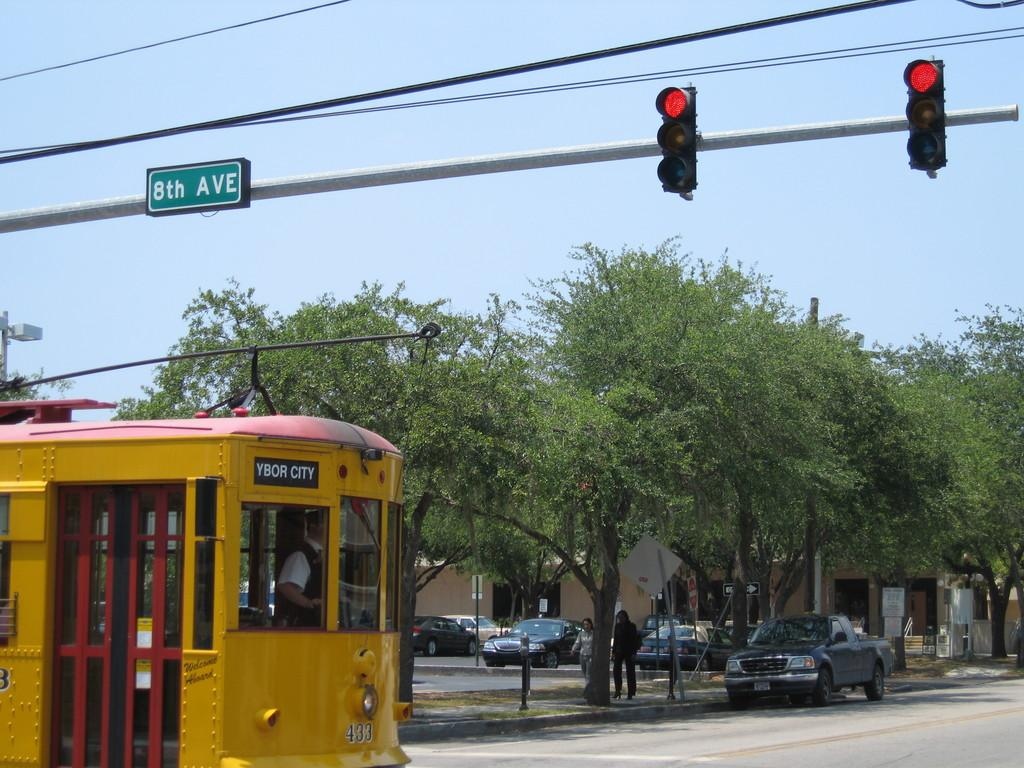<image>
Write a terse but informative summary of the picture. A trolley traveling on 8th ave with a Ybor city sign on it. 